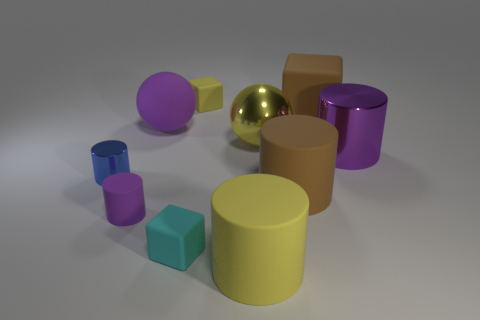Subtract 2 cylinders. How many cylinders are left? 3 Subtract all purple blocks. Subtract all green cylinders. How many blocks are left? 3 Subtract all blocks. How many objects are left? 7 Add 7 yellow metallic cubes. How many yellow metallic cubes exist? 7 Subtract 1 purple spheres. How many objects are left? 9 Subtract all big red matte things. Subtract all big yellow things. How many objects are left? 8 Add 7 big purple metal cylinders. How many big purple metal cylinders are left? 8 